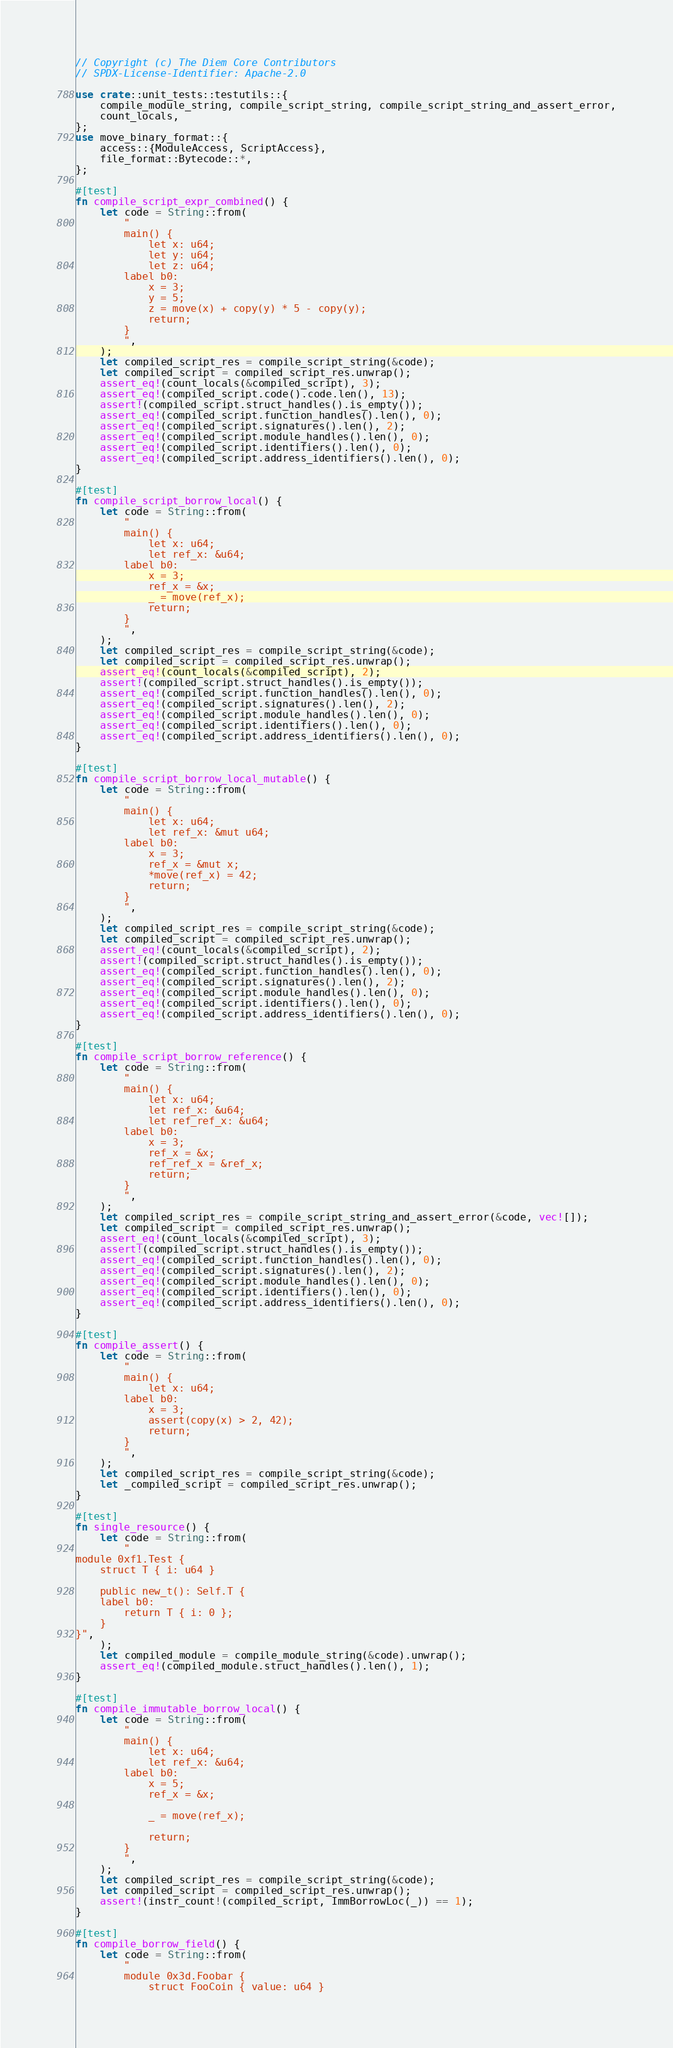Convert code to text. <code><loc_0><loc_0><loc_500><loc_500><_Rust_>// Copyright (c) The Diem Core Contributors
// SPDX-License-Identifier: Apache-2.0

use crate::unit_tests::testutils::{
    compile_module_string, compile_script_string, compile_script_string_and_assert_error,
    count_locals,
};
use move_binary_format::{
    access::{ModuleAccess, ScriptAccess},
    file_format::Bytecode::*,
};

#[test]
fn compile_script_expr_combined() {
    let code = String::from(
        "
        main() {
            let x: u64;
            let y: u64;
            let z: u64;
        label b0:
            x = 3;
            y = 5;
            z = move(x) + copy(y) * 5 - copy(y);
            return;
        }
        ",
    );
    let compiled_script_res = compile_script_string(&code);
    let compiled_script = compiled_script_res.unwrap();
    assert_eq!(count_locals(&compiled_script), 3);
    assert_eq!(compiled_script.code().code.len(), 13);
    assert!(compiled_script.struct_handles().is_empty());
    assert_eq!(compiled_script.function_handles().len(), 0);
    assert_eq!(compiled_script.signatures().len(), 2);
    assert_eq!(compiled_script.module_handles().len(), 0);
    assert_eq!(compiled_script.identifiers().len(), 0);
    assert_eq!(compiled_script.address_identifiers().len(), 0);
}

#[test]
fn compile_script_borrow_local() {
    let code = String::from(
        "
        main() {
            let x: u64;
            let ref_x: &u64;
        label b0:
            x = 3;
            ref_x = &x;
            _ = move(ref_x);
            return;
        }
        ",
    );
    let compiled_script_res = compile_script_string(&code);
    let compiled_script = compiled_script_res.unwrap();
    assert_eq!(count_locals(&compiled_script), 2);
    assert!(compiled_script.struct_handles().is_empty());
    assert_eq!(compiled_script.function_handles().len(), 0);
    assert_eq!(compiled_script.signatures().len(), 2);
    assert_eq!(compiled_script.module_handles().len(), 0);
    assert_eq!(compiled_script.identifiers().len(), 0);
    assert_eq!(compiled_script.address_identifiers().len(), 0);
}

#[test]
fn compile_script_borrow_local_mutable() {
    let code = String::from(
        "
        main() {
            let x: u64;
            let ref_x: &mut u64;
        label b0:
            x = 3;
            ref_x = &mut x;
            *move(ref_x) = 42;
            return;
        }
        ",
    );
    let compiled_script_res = compile_script_string(&code);
    let compiled_script = compiled_script_res.unwrap();
    assert_eq!(count_locals(&compiled_script), 2);
    assert!(compiled_script.struct_handles().is_empty());
    assert_eq!(compiled_script.function_handles().len(), 0);
    assert_eq!(compiled_script.signatures().len(), 2);
    assert_eq!(compiled_script.module_handles().len(), 0);
    assert_eq!(compiled_script.identifiers().len(), 0);
    assert_eq!(compiled_script.address_identifiers().len(), 0);
}

#[test]
fn compile_script_borrow_reference() {
    let code = String::from(
        "
        main() {
            let x: u64;
            let ref_x: &u64;
            let ref_ref_x: &u64;
        label b0:
            x = 3;
            ref_x = &x;
            ref_ref_x = &ref_x;
            return;
        }
        ",
    );
    let compiled_script_res = compile_script_string_and_assert_error(&code, vec![]);
    let compiled_script = compiled_script_res.unwrap();
    assert_eq!(count_locals(&compiled_script), 3);
    assert!(compiled_script.struct_handles().is_empty());
    assert_eq!(compiled_script.function_handles().len(), 0);
    assert_eq!(compiled_script.signatures().len(), 2);
    assert_eq!(compiled_script.module_handles().len(), 0);
    assert_eq!(compiled_script.identifiers().len(), 0);
    assert_eq!(compiled_script.address_identifiers().len(), 0);
}

#[test]
fn compile_assert() {
    let code = String::from(
        "
        main() {
            let x: u64;
        label b0:
            x = 3;
            assert(copy(x) > 2, 42);
            return;
        }
        ",
    );
    let compiled_script_res = compile_script_string(&code);
    let _compiled_script = compiled_script_res.unwrap();
}

#[test]
fn single_resource() {
    let code = String::from(
        "
module 0xf1.Test {
    struct T { i: u64 }

    public new_t(): Self.T {
    label b0:
        return T { i: 0 };
    }
}",
    );
    let compiled_module = compile_module_string(&code).unwrap();
    assert_eq!(compiled_module.struct_handles().len(), 1);
}

#[test]
fn compile_immutable_borrow_local() {
    let code = String::from(
        "
        main() {
            let x: u64;
            let ref_x: &u64;
        label b0:
            x = 5;
            ref_x = &x;

            _ = move(ref_x);

            return;
        }
        ",
    );
    let compiled_script_res = compile_script_string(&code);
    let compiled_script = compiled_script_res.unwrap();
    assert!(instr_count!(compiled_script, ImmBorrowLoc(_)) == 1);
}

#[test]
fn compile_borrow_field() {
    let code = String::from(
        "
        module 0x3d.Foobar {
            struct FooCoin { value: u64 }
</code> 